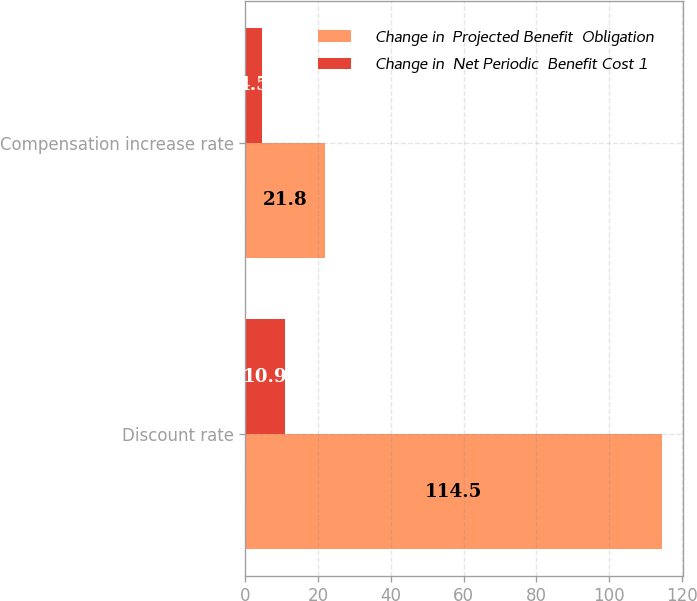Convert chart. <chart><loc_0><loc_0><loc_500><loc_500><stacked_bar_chart><ecel><fcel>Discount rate<fcel>Compensation increase rate<nl><fcel>Change in  Projected Benefit  Obligation<fcel>114.5<fcel>21.8<nl><fcel>Change in  Net Periodic  Benefit Cost 1<fcel>10.9<fcel>4.5<nl></chart> 